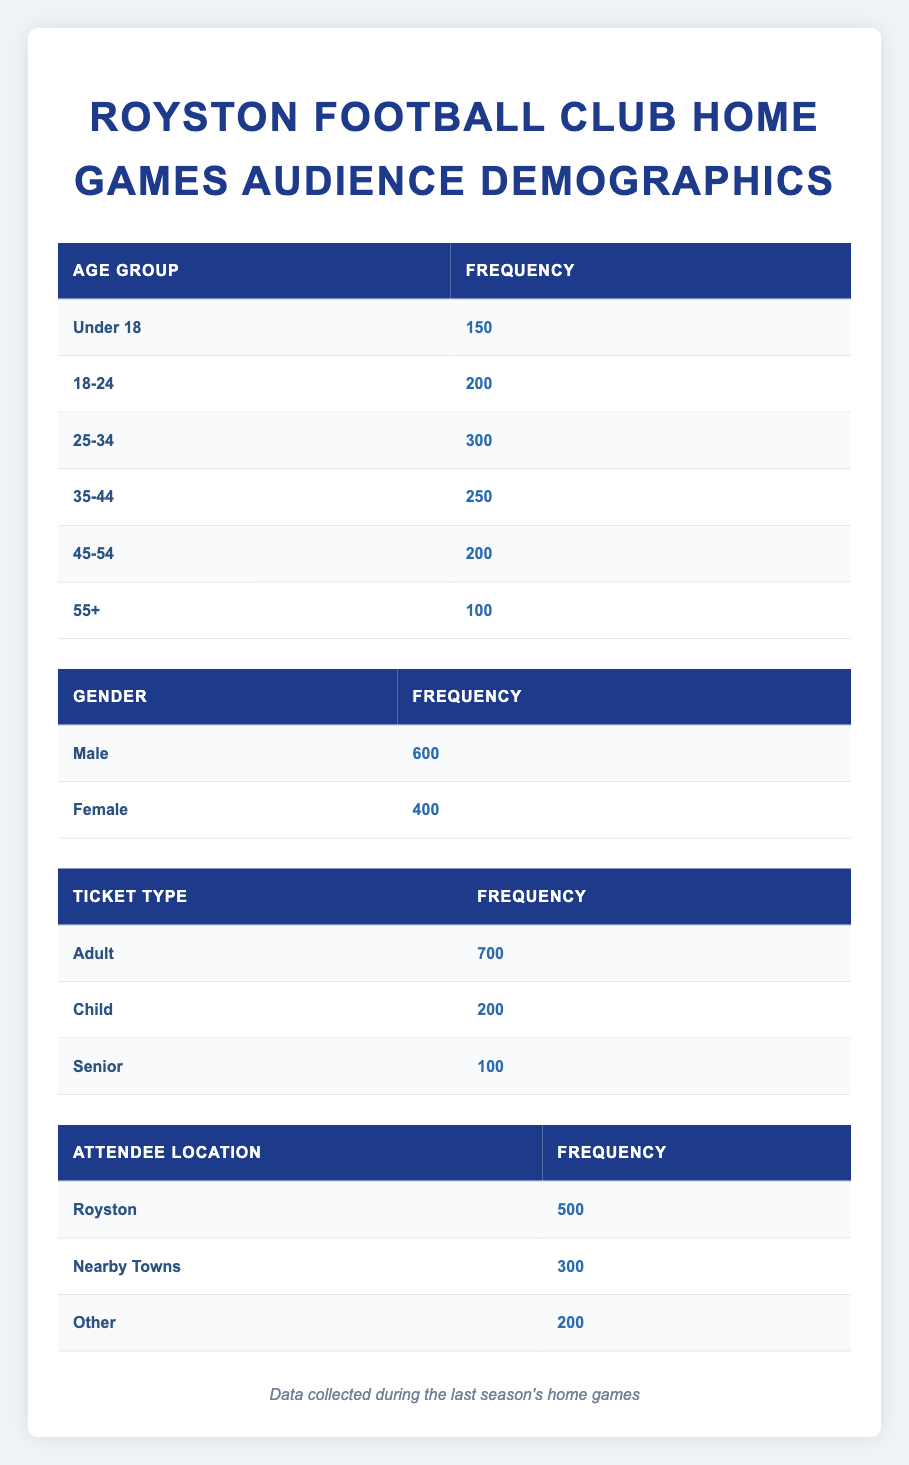What is the total number of attendees under the age of 18? The table indicates that the number of attendees in the "Under 18" age group is 150. Thus, this is the total number of attendees in that age group.
Answer: 150 What percentage of the total audience is female? The total audience is calculated by summing up all attendees across genders. There are 600 males and 400 females, leading to a total of 1000. The percentage of females is (400/1000) * 100 = 40%.
Answer: 40% How many more adult tickets were sold compared to child tickets? According to the table, there were 700 adult tickets sold and 200 child tickets sold. The difference is calculated as 700 - 200 = 500.
Answer: 500 Is the number of attendees from Royston greater than those from nearby towns? The table shows there are 500 attendees from Royston and 300 from nearby towns. Since 500 is greater than 300, the answer is yes.
Answer: Yes What is the average age group attendance for the 25-34 and 35-44 age groups? The attendance for the 25-34 age group is 300 and for the 35-44 age group is 250. To find the average, sum the two values: 300 + 250 = 550. Then divide by 2 (the number of groups), resulting in an average of 550/2 = 275.
Answer: 275 What is the total number of attendees that are seniors or children? The "Senior" ticket count is 100 and "Child" ticket count is 200. To find the total, we sum these two numbers: 100 + 200 = 300.
Answer: 300 How many attendees are in the age group of 45-54? From the table, the number of attendees in the 45-54 age group is stated to be 200. Hence, this is the answer.
Answer: 200 What is the total number of attendees residing outside of Royston? From the table, the total for "Nearby Towns" is 300 and "Other" is 200. Adding these together gives us 300 + 200 = 500. So, the total number of attendees residing outside Royston is 500.
Answer: 500 Is the majority of the audience male? The total male audience is 600, while the female audience is 400. Since 600 is greater than 400, the majority is male. Thus, the answer is yes.
Answer: Yes 